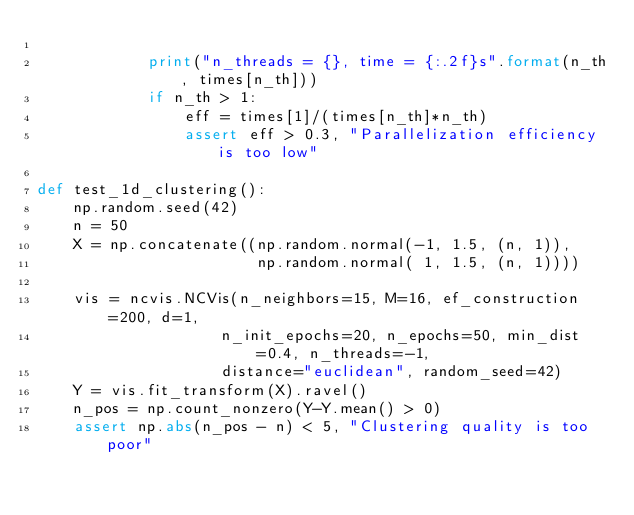Convert code to text. <code><loc_0><loc_0><loc_500><loc_500><_Python_>
            print("n_threads = {}, time = {:.2f}s".format(n_th, times[n_th]))
            if n_th > 1:
                eff = times[1]/(times[n_th]*n_th)
                assert eff > 0.3, "Parallelization efficiency is too low"

def test_1d_clustering():
    np.random.seed(42)
    n = 50
    X = np.concatenate((np.random.normal(-1, 1.5, (n, 1)), 
                        np.random.normal( 1, 1.5, (n, 1))))

    vis = ncvis.NCVis(n_neighbors=15, M=16, ef_construction=200, d=1,
                    n_init_epochs=20, n_epochs=50, min_dist=0.4, n_threads=-1, 
                    distance="euclidean", random_seed=42)
    Y = vis.fit_transform(X).ravel()
    n_pos = np.count_nonzero(Y-Y.mean() > 0)
    assert np.abs(n_pos - n) < 5, "Clustering quality is too poor"</code> 